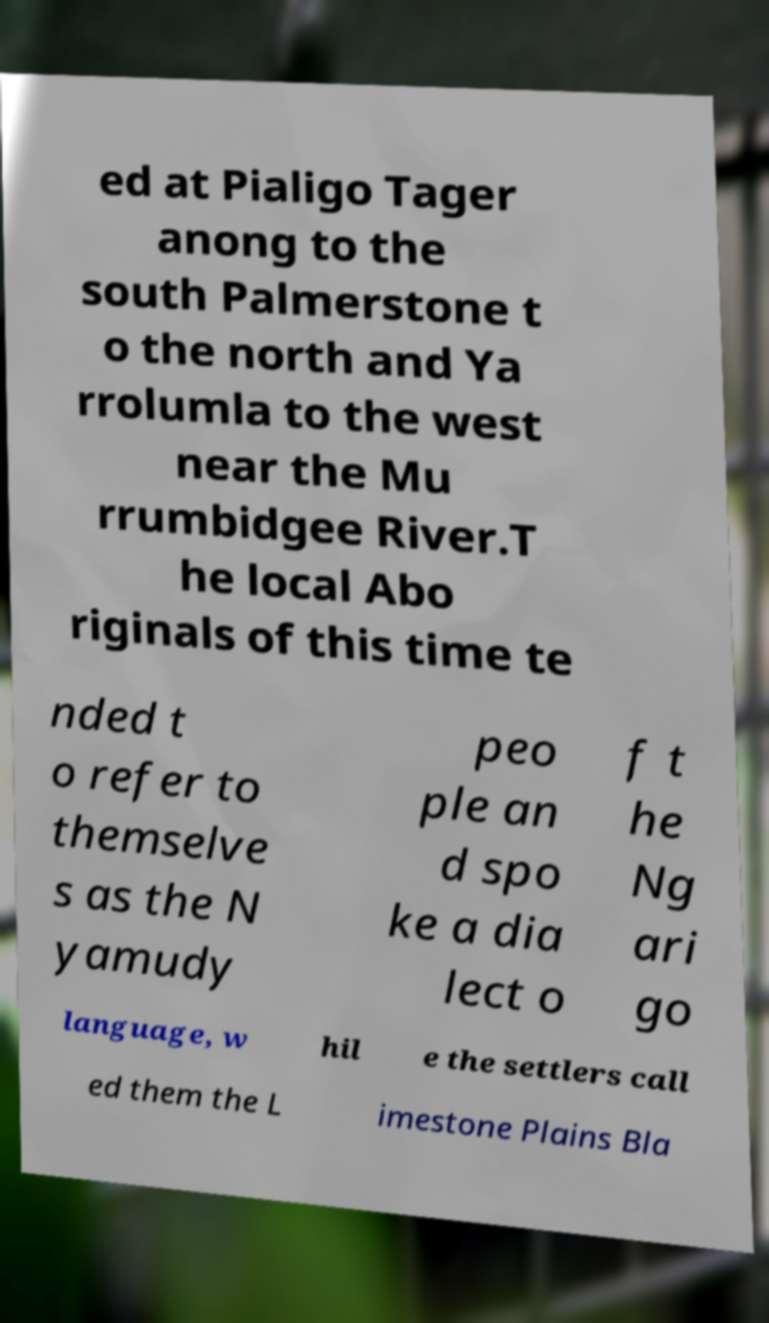Can you read and provide the text displayed in the image?This photo seems to have some interesting text. Can you extract and type it out for me? ed at Pialigo Tager anong to the south Palmerstone t o the north and Ya rrolumla to the west near the Mu rrumbidgee River.T he local Abo riginals of this time te nded t o refer to themselve s as the N yamudy peo ple an d spo ke a dia lect o f t he Ng ari go language, w hil e the settlers call ed them the L imestone Plains Bla 